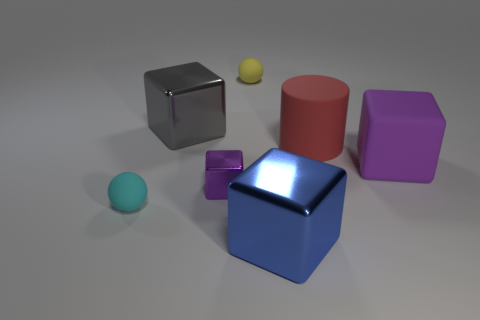Do the shiny object that is behind the purple rubber block and the purple block that is right of the yellow object have the same size?
Offer a very short reply. Yes. How many objects are red matte cylinders or small gray metallic cylinders?
Make the answer very short. 1. The big gray metallic object has what shape?
Your answer should be very brief. Cube. What size is the gray thing that is the same shape as the blue object?
Make the answer very short. Large. Are there any other things that are made of the same material as the tiny cyan object?
Make the answer very short. Yes. There is a shiny block behind the big purple rubber cube on the right side of the gray thing; how big is it?
Make the answer very short. Large. Are there the same number of red matte things in front of the large red cylinder and blocks?
Ensure brevity in your answer.  No. How many other things are the same color as the small metallic cube?
Offer a terse response. 1. Is the number of metallic things that are in front of the purple shiny block less than the number of big blue matte cubes?
Provide a succinct answer. No. Are there any yellow balls of the same size as the red cylinder?
Provide a short and direct response. No. 